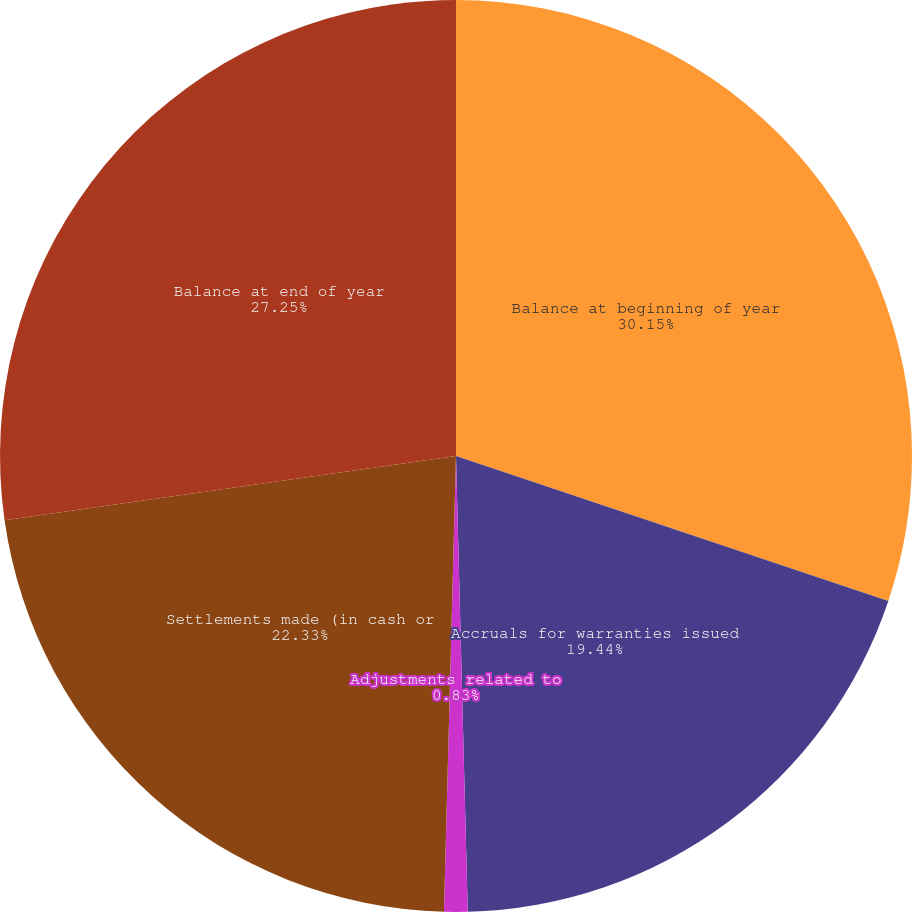Convert chart. <chart><loc_0><loc_0><loc_500><loc_500><pie_chart><fcel>Balance at beginning of year<fcel>Accruals for warranties issued<fcel>Adjustments related to<fcel>Settlements made (in cash or<fcel>Balance at end of year<nl><fcel>30.15%<fcel>19.44%<fcel>0.83%<fcel>22.33%<fcel>27.25%<nl></chart> 